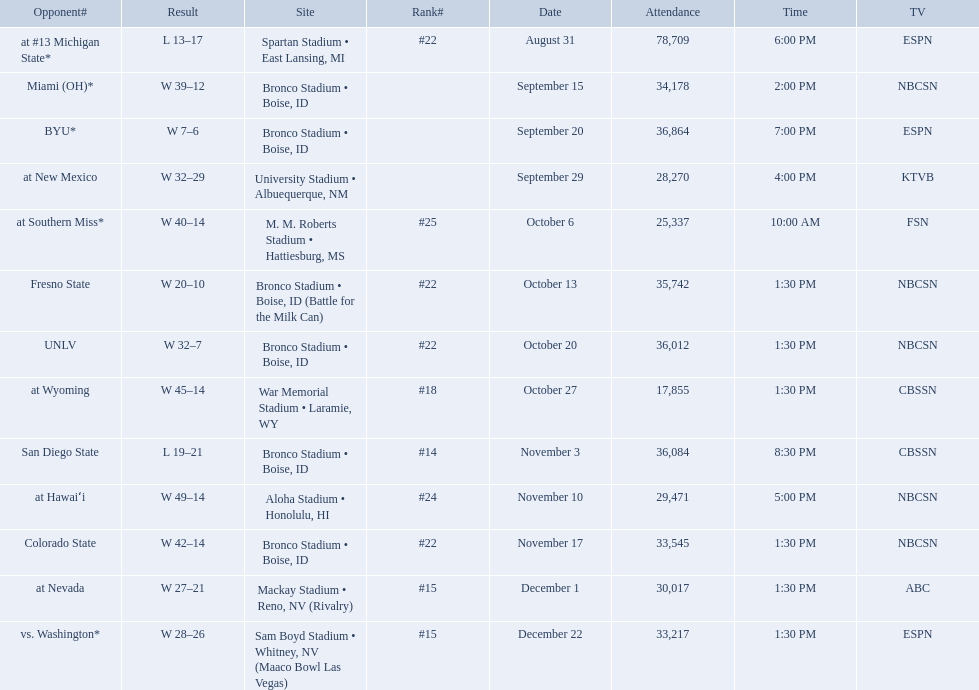Who were all the opponents for boise state? At #13 michigan state*, miami (oh)*, byu*, at new mexico, at southern miss*, fresno state, unlv, at wyoming, san diego state, at hawaiʻi, colorado state, at nevada, vs. washington*. Which opponents were ranked? At #13 michigan state*, #22, at southern miss*, #25, fresno state, #22, unlv, #22, at wyoming, #18, san diego state, #14. Which opponent had the highest rank? San Diego State. 